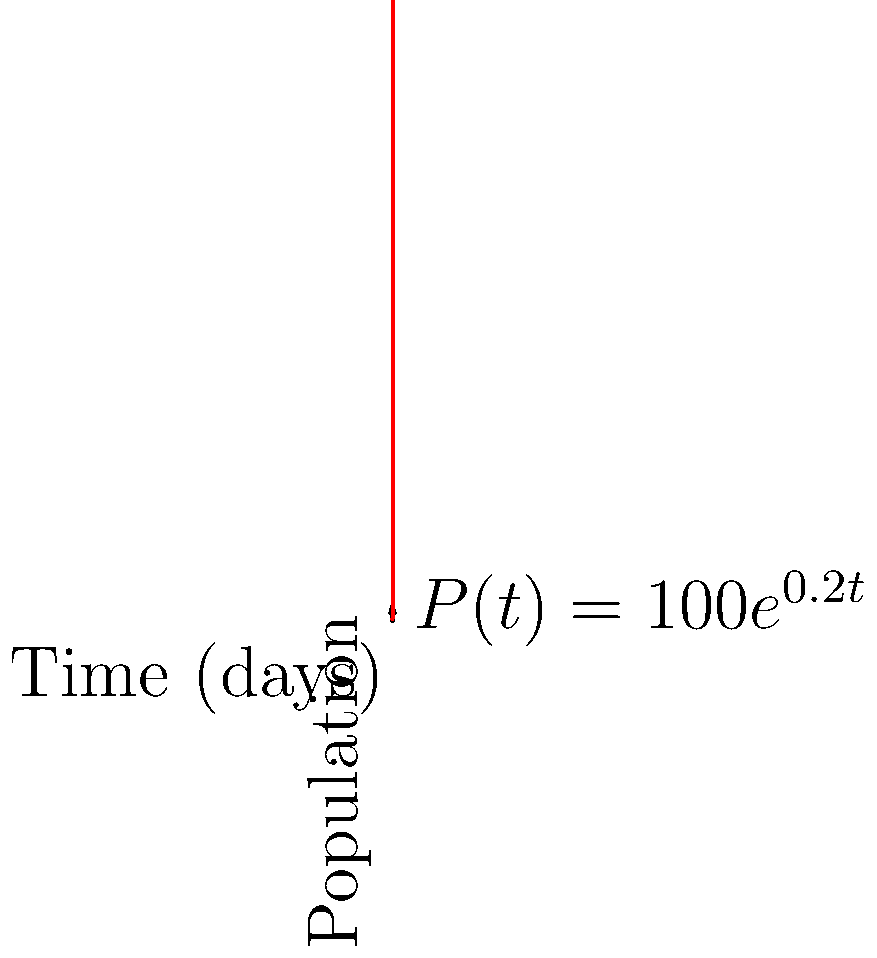As a botanist studying a rare plant species, you observe its population growth over time. The graph shows the exponential growth function $P(t) = 100e^{0.2t}$, where $P$ is the population and $t$ is time in days. How many days will it take for the population to reach 800 plants? To solve this problem, we need to use the given exponential growth function and solve for t when P = 800.

1) The given function is $P(t) = 100e^{0.2t}$

2) We want to find t when P = 800, so we set up the equation:
   $800 = 100e^{0.2t}$

3) Divide both sides by 100:
   $8 = e^{0.2t}$

4) Take the natural logarithm of both sides:
   $\ln(8) = \ln(e^{0.2t})$

5) Simplify the right side using the property of logarithms:
   $\ln(8) = 0.2t$

6) Divide both sides by 0.2:
   $\frac{\ln(8)}{0.2} = t$

7) Calculate the value:
   $t \approx 10.39$ days

8) Since we're dealing with whole plants, we round up to the nearest day.

Therefore, it will take 11 days for the population to reach 800 plants.
Answer: 11 days 